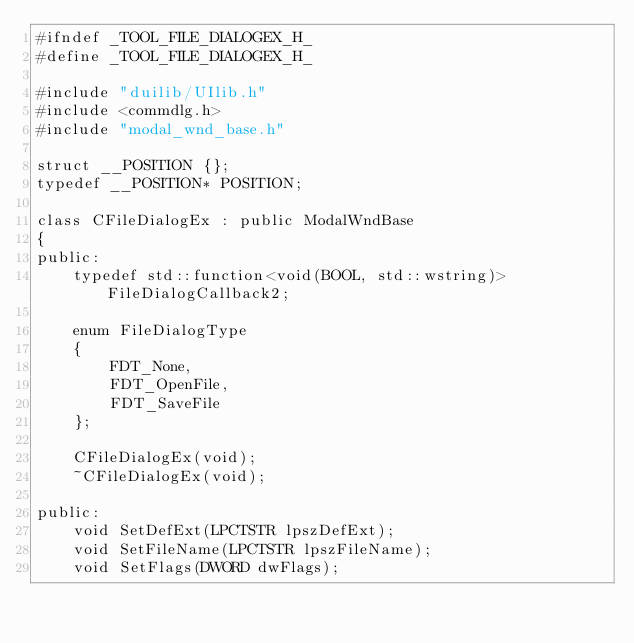<code> <loc_0><loc_0><loc_500><loc_500><_C_>#ifndef _TOOL_FILE_DIALOGEX_H_
#define _TOOL_FILE_DIALOGEX_H_

#include "duilib/UIlib.h"
#include <commdlg.h>
#include "modal_wnd_base.h"

struct __POSITION {};
typedef __POSITION* POSITION;

class CFileDialogEx : public ModalWndBase
{
public:
	typedef std::function<void(BOOL, std::wstring)> FileDialogCallback2;

	enum FileDialogType
	{
		FDT_None,
		FDT_OpenFile,
		FDT_SaveFile
	};

	CFileDialogEx(void);
	~CFileDialogEx(void);

public:
	void SetDefExt(LPCTSTR lpszDefExt);
	void SetFileName(LPCTSTR lpszFileName);
	void SetFlags(DWORD dwFlags);</code> 